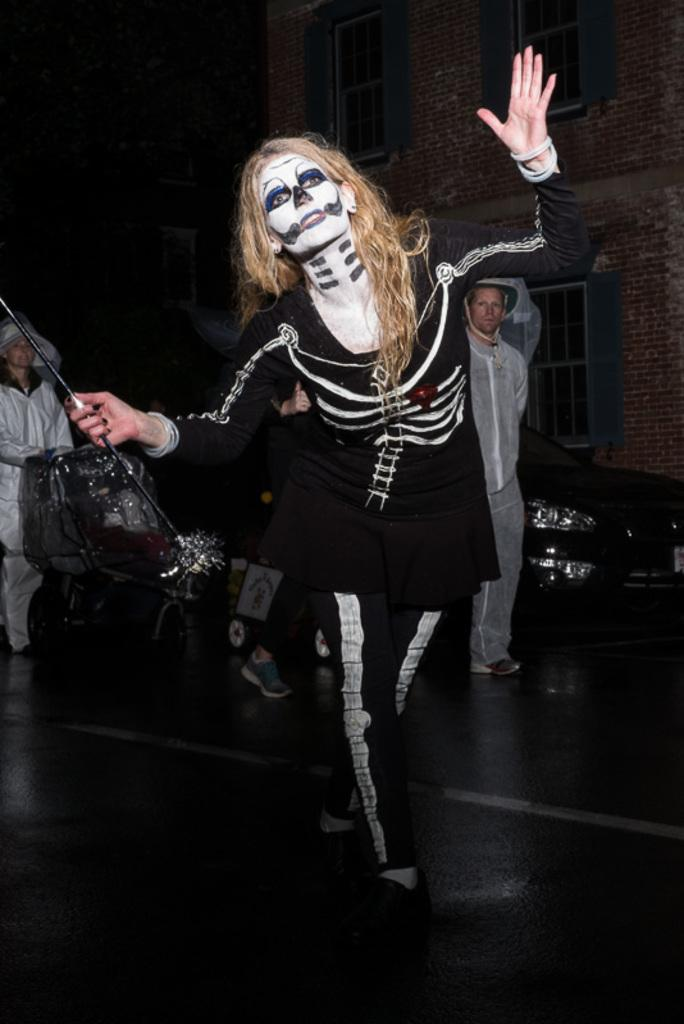Who is the main subject in the image? There is a woman in the image. What is the woman doing in the image? The woman is in motion. What is the woman holding in the image? The woman is holding a stick. What can be seen in the background of the image? There are people, windows, a wall, and a car in the background of the image. What type of fowl can be seen flying through space in the image? There is no fowl or space present in the image; it features a woman in motion holding a stick with a background that includes people, windows, a wall, and a car. 